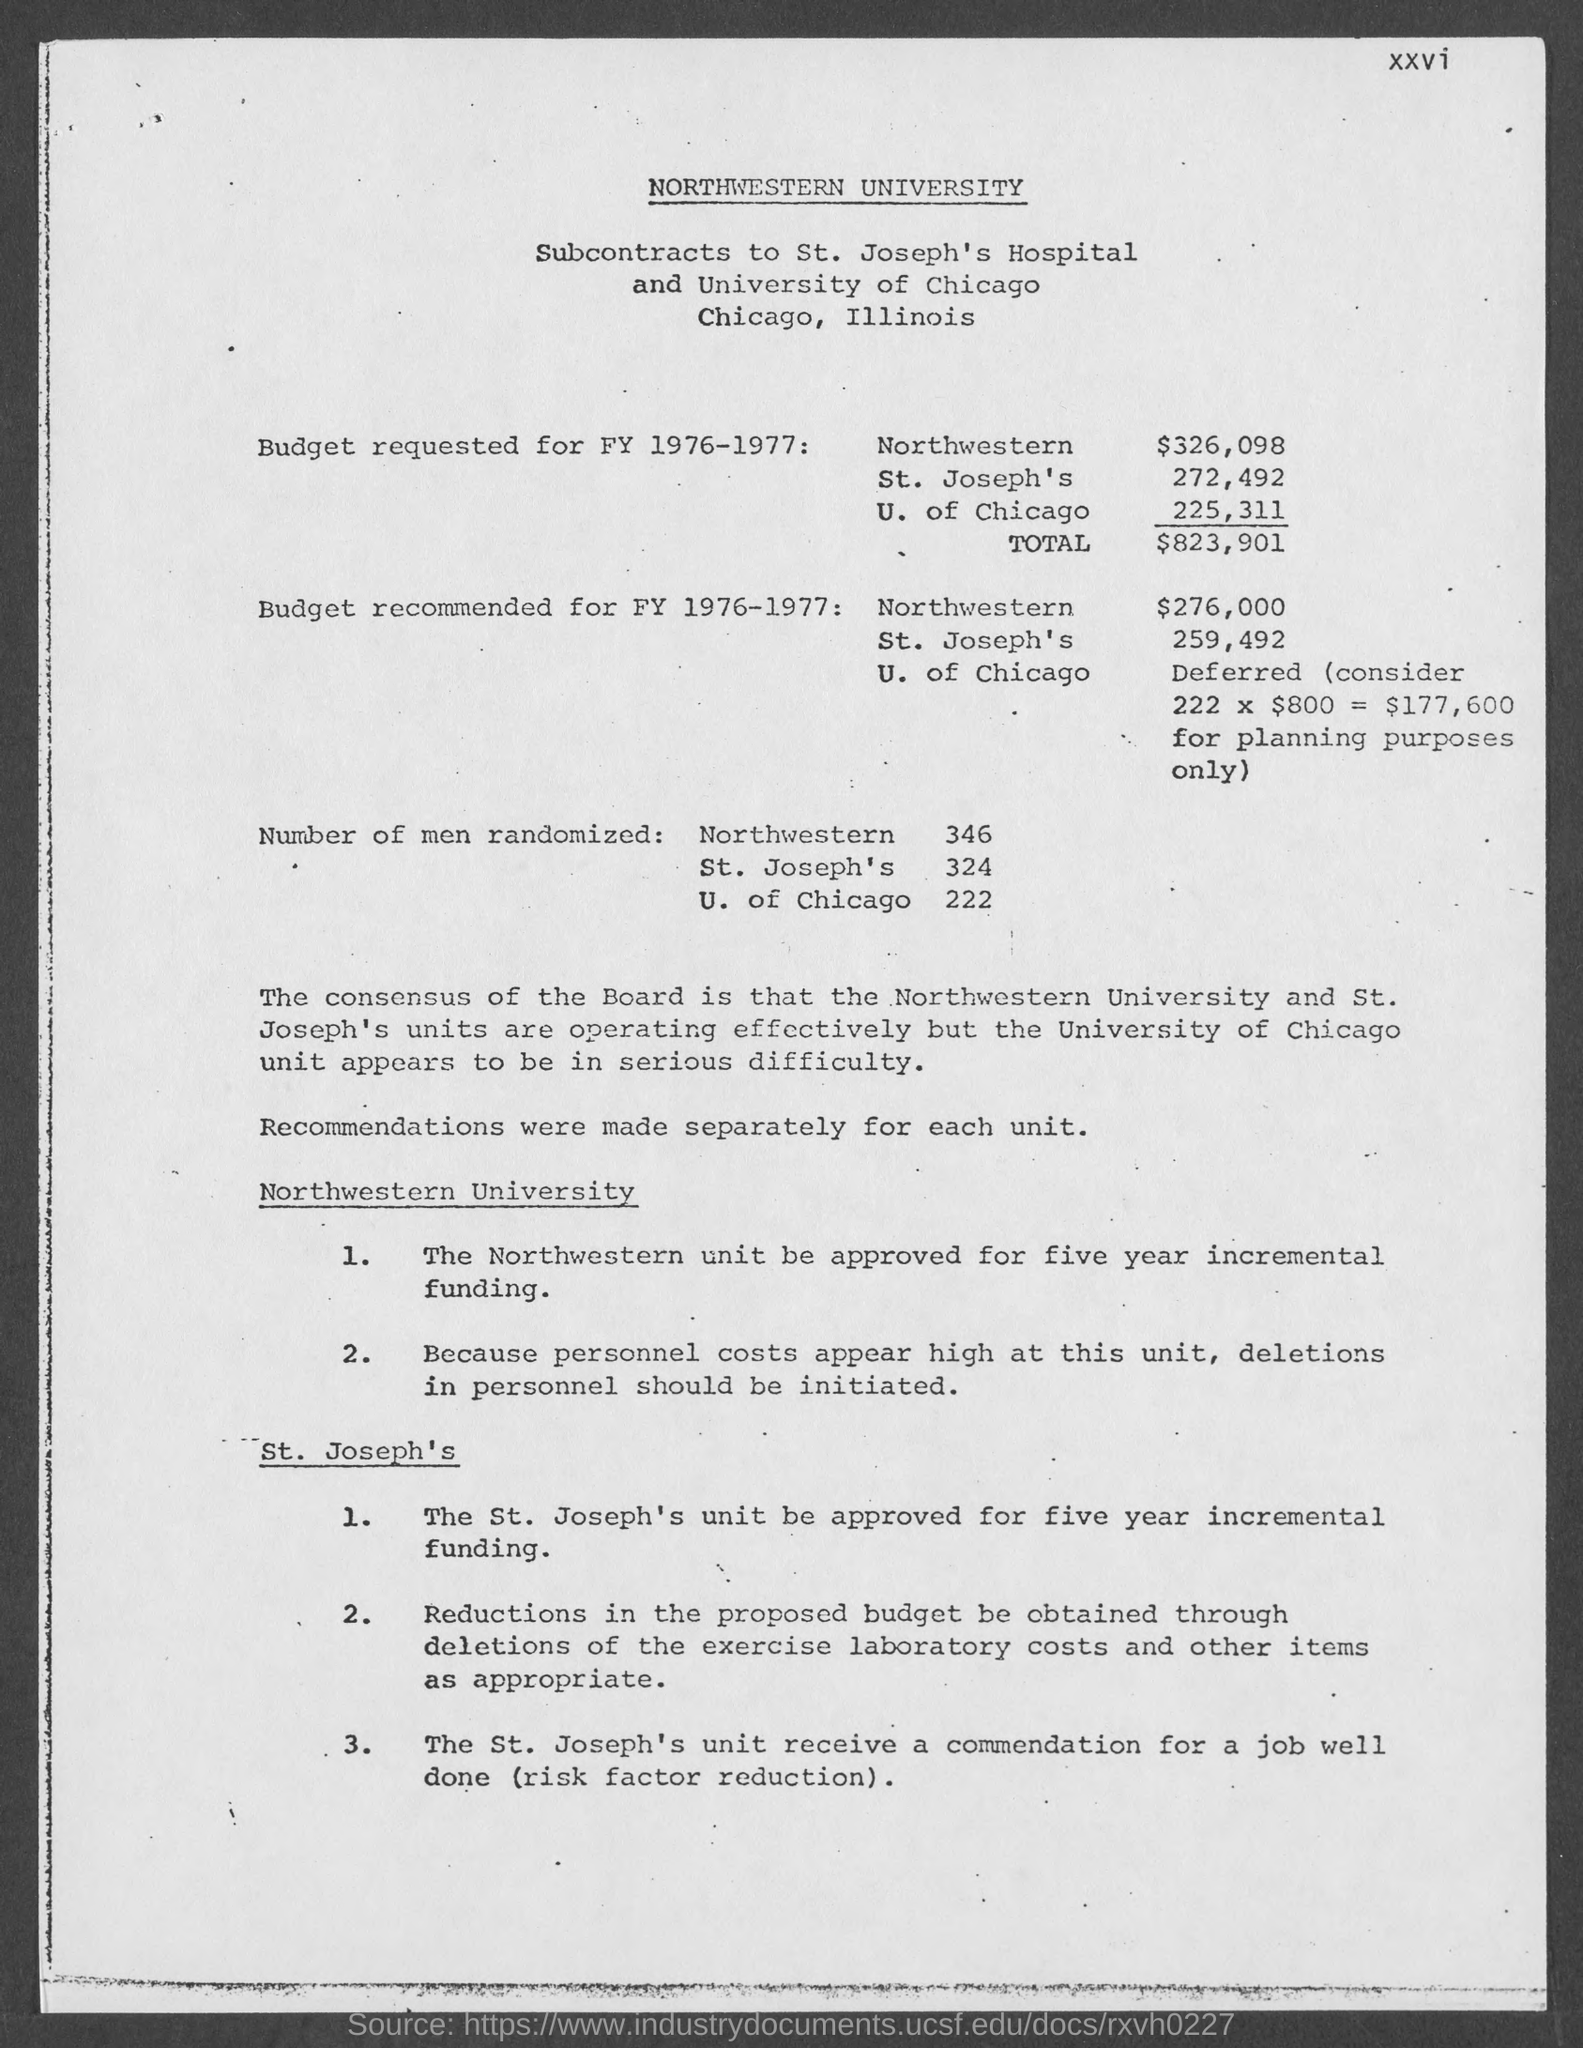Mention a couple of crucial points in this snapshot. There are 324 randomized men in St. Joseph's. The budget for Northwestern for fiscal year 1976-1977 is recommended to be $276,000. The budget requested for FY 1976-1977 in total is $823,901. The University of Chicago randomly selected 222 men for a study. The budget requested for FY 1976-1977 at Northwestern is $326,098. 